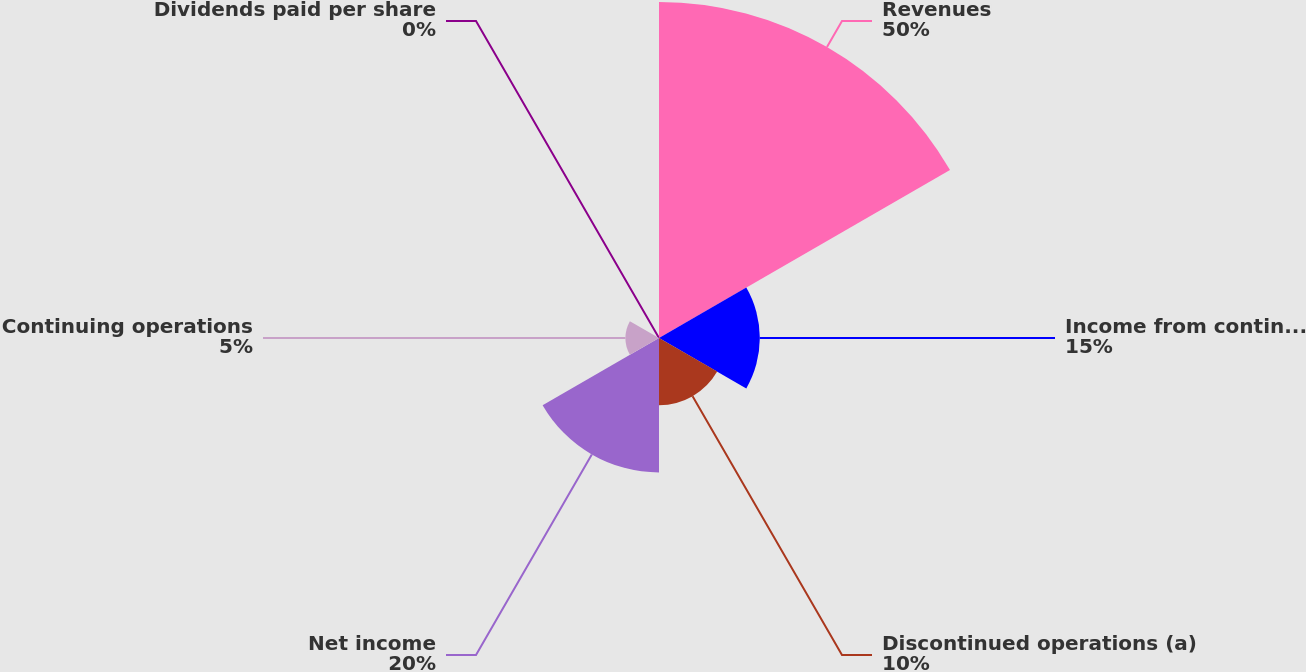Convert chart to OTSL. <chart><loc_0><loc_0><loc_500><loc_500><pie_chart><fcel>Revenues<fcel>Income from continuing<fcel>Discontinued operations (a)<fcel>Net income<fcel>Continuing operations<fcel>Dividends paid per share<nl><fcel>50.0%<fcel>15.0%<fcel>10.0%<fcel>20.0%<fcel>5.0%<fcel>0.0%<nl></chart> 